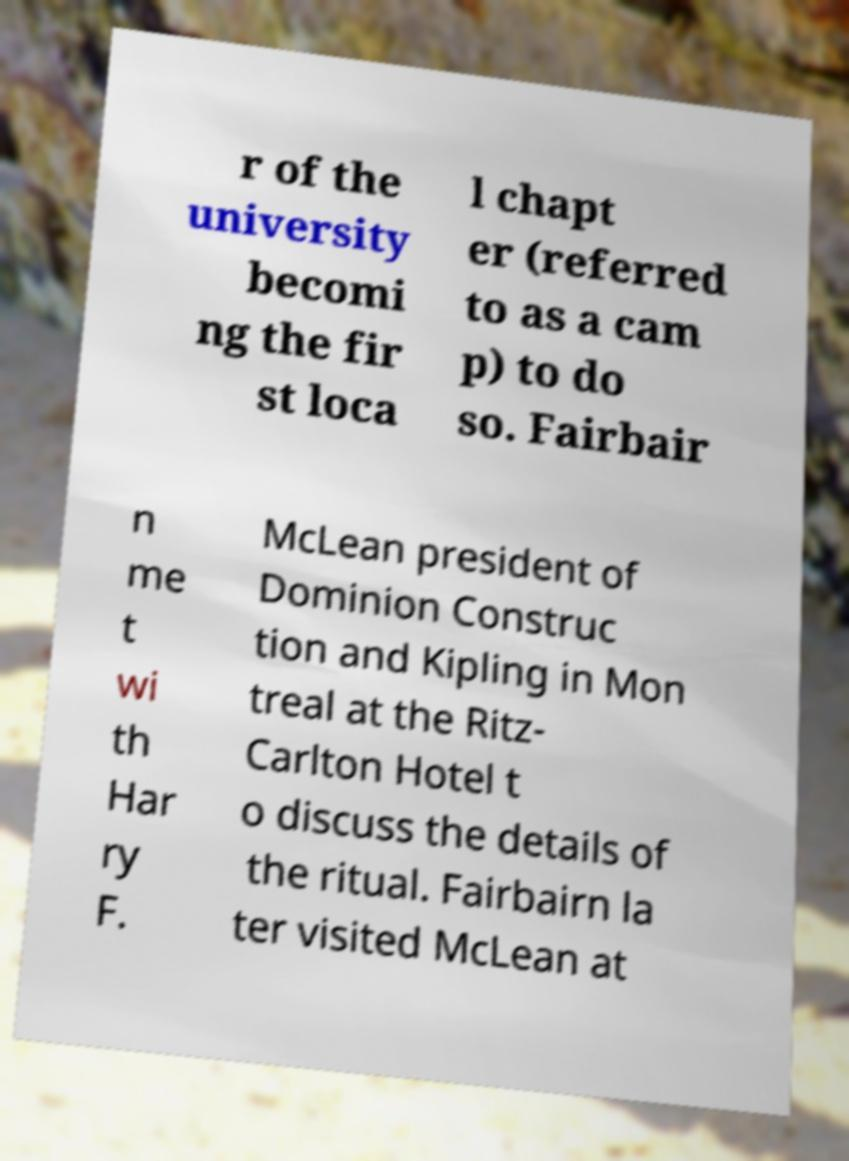Could you assist in decoding the text presented in this image and type it out clearly? r of the university becomi ng the fir st loca l chapt er (referred to as a cam p) to do so. Fairbair n me t wi th Har ry F. McLean president of Dominion Construc tion and Kipling in Mon treal at the Ritz- Carlton Hotel t o discuss the details of the ritual. Fairbairn la ter visited McLean at 